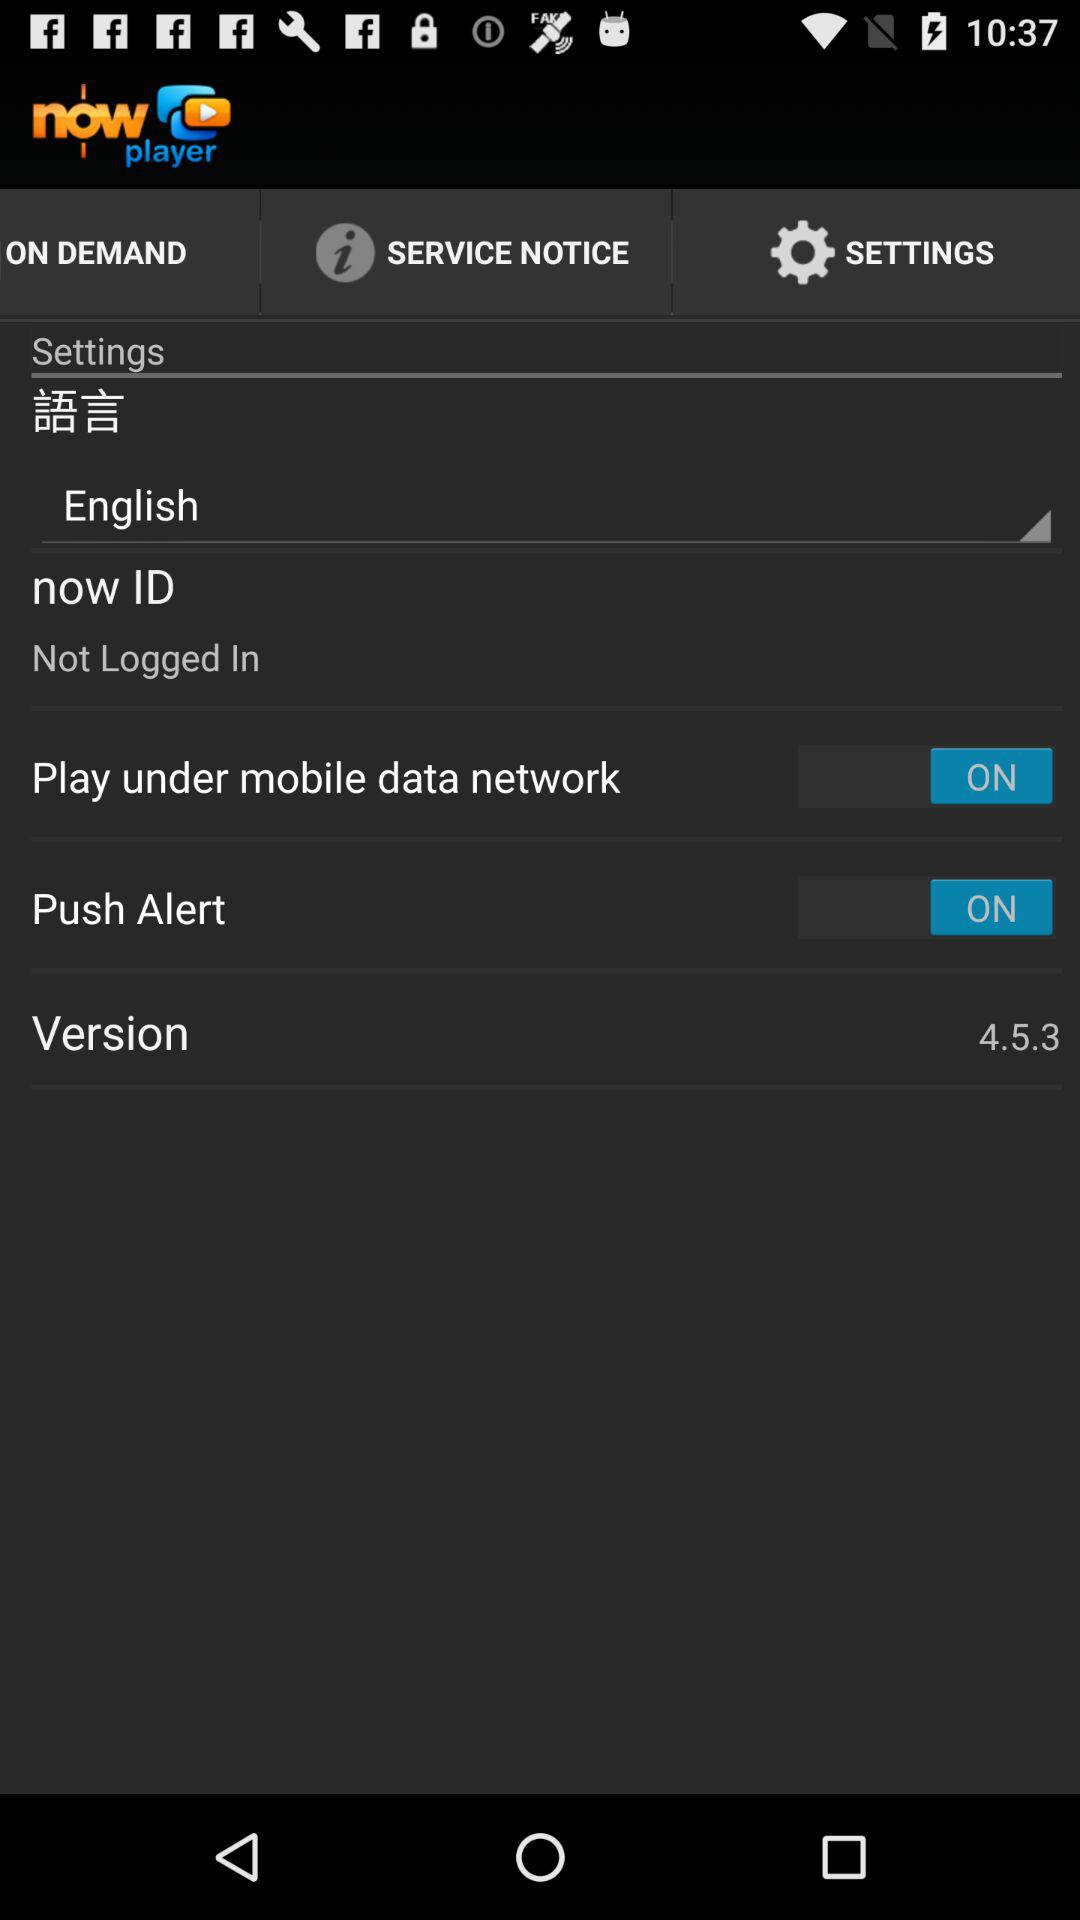How many switches are there in the settings screen?
Answer the question using a single word or phrase. 2 